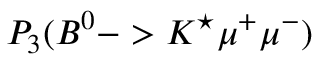<formula> <loc_0><loc_0><loc_500><loc_500>P _ { 3 } ( B ^ { 0 } - > K ^ { ^ { * } } \mu ^ { + } \mu ^ { - } )</formula> 